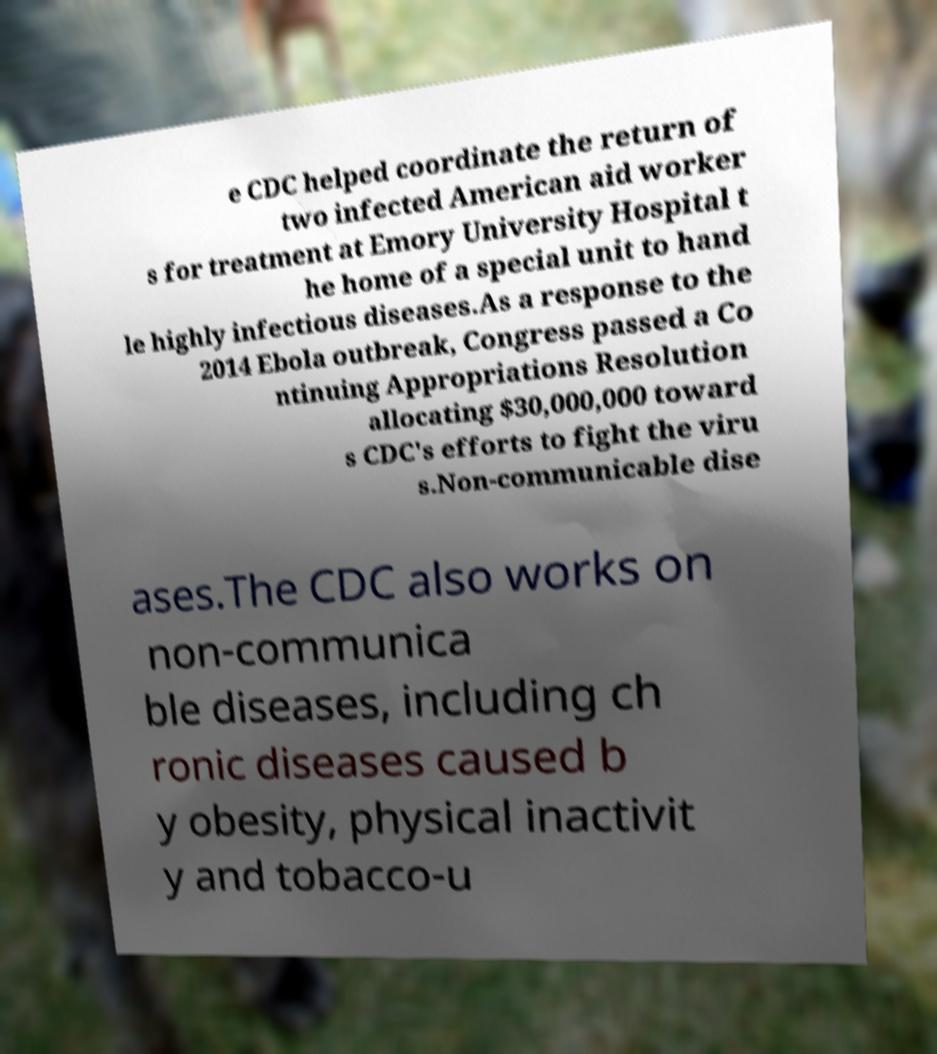Can you read and provide the text displayed in the image?This photo seems to have some interesting text. Can you extract and type it out for me? e CDC helped coordinate the return of two infected American aid worker s for treatment at Emory University Hospital t he home of a special unit to hand le highly infectious diseases.As a response to the 2014 Ebola outbreak, Congress passed a Co ntinuing Appropriations Resolution allocating $30,000,000 toward s CDC's efforts to fight the viru s.Non-communicable dise ases.The CDC also works on non-communica ble diseases, including ch ronic diseases caused b y obesity, physical inactivit y and tobacco-u 